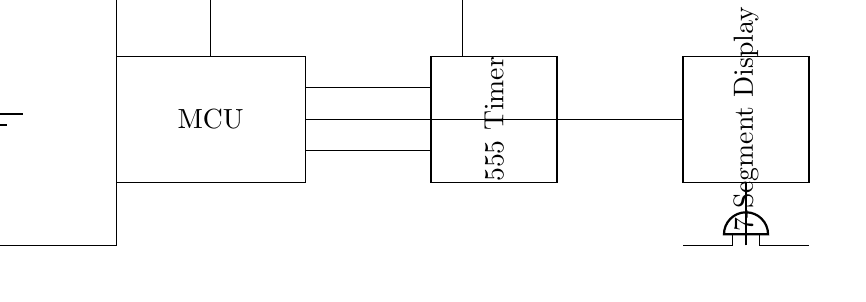What is the power supply voltage? The power supply in the circuit is labeled as 5V, which indicates the voltage provided to the circuit.
Answer: 5V What component is used for timing? The circuit includes a 555 Timer, specifically designed for timing applications. It is a widely used component in various timer and oscillator circuits.
Answer: 555 Timer How many push buttons are in the circuit? There are two push buttons shown in the circuit diagram: one for Start/Stop and the other for Reset, making a total of two push buttons.
Answer: 2 What is the function of the 7-segment display? The 7-segment display visually represents numerical data. In this context, it shows the tracked time or performance metrics of the gymnast.
Answer: Display time Which component signals the end of the timer? The buzzer serves as the signaling device, sounding when the timing period is over, alerting the user.
Answer: Buzzer How is the Start/Stop button connected to the circuit? The Start/Stop button is connected to the microcontroller, which controls the timing operation based on the button's state. This indicates its role in starting or stopping the timer.
Answer: To microcontroller Explain the connection between the microcontroller and the 7-segment display. The microcontroller outputs signals to the 7-segment display, enabling it to show the timing information processed by the microcontroller, thus linking them functionally in the circuit.
Answer: Direct connection 